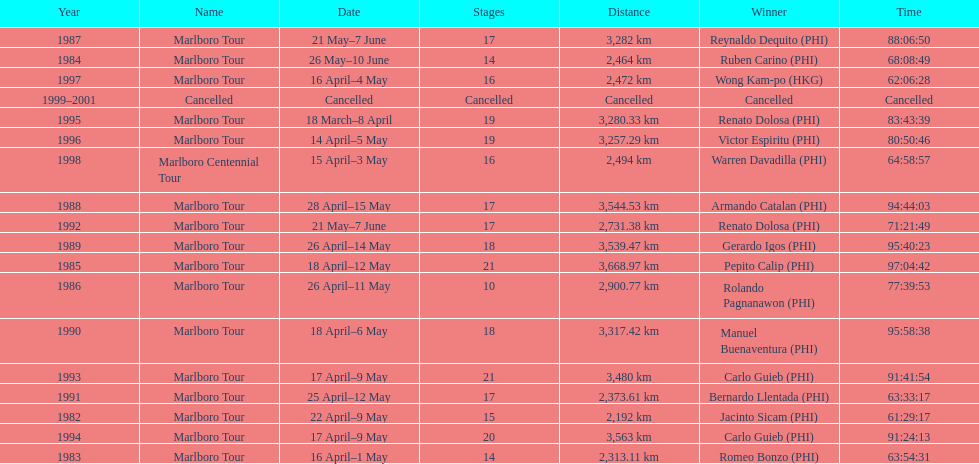What was the total number of winners before the tour was canceled? 17. 